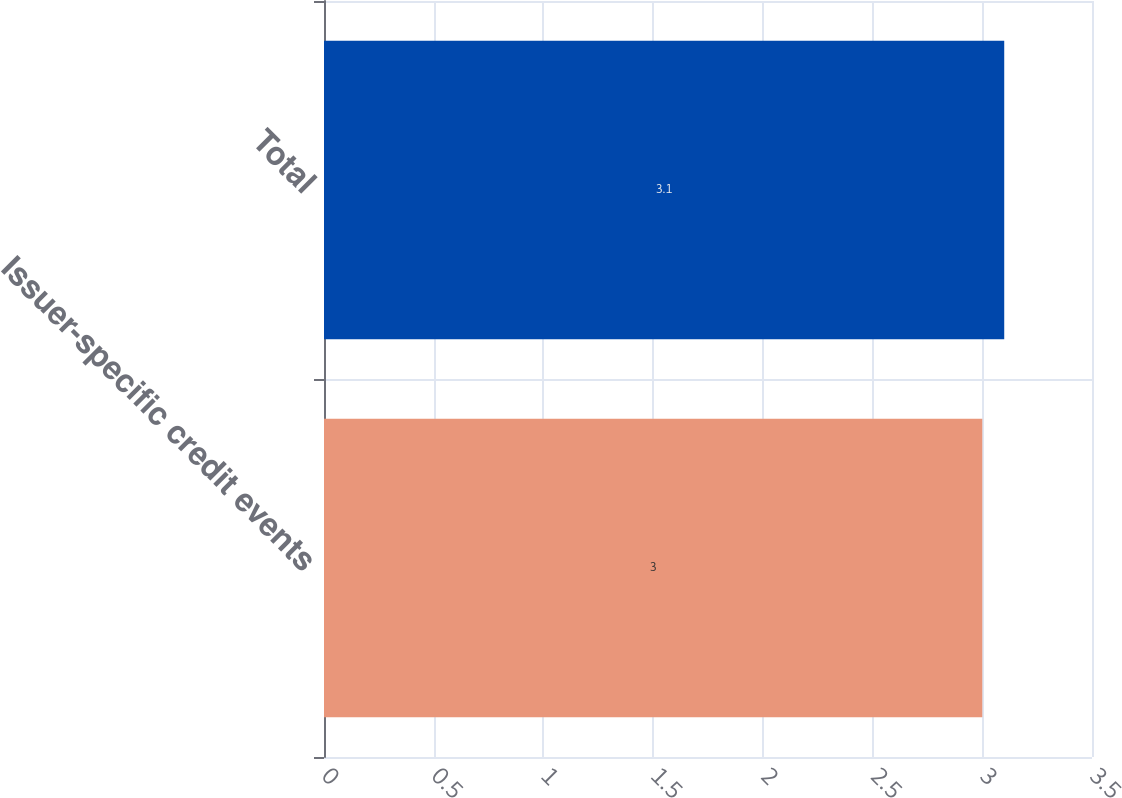Convert chart to OTSL. <chart><loc_0><loc_0><loc_500><loc_500><bar_chart><fcel>Issuer-specific credit events<fcel>Total<nl><fcel>3<fcel>3.1<nl></chart> 